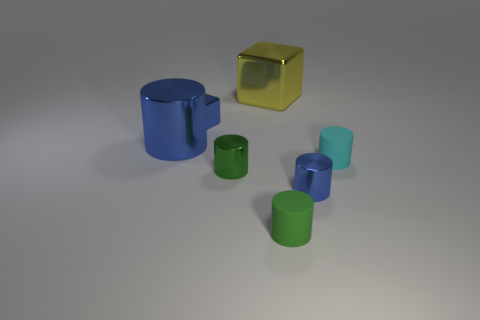Is there any other thing that is the same color as the big block?
Offer a terse response. No. There is a blue block; are there any big yellow objects on the right side of it?
Your answer should be very brief. Yes. Is the shape of the blue shiny object in front of the cyan rubber cylinder the same as  the large yellow object?
Provide a succinct answer. No. How many large things have the same color as the big metallic block?
Give a very brief answer. 0. There is a blue object that is in front of the large object in front of the yellow thing; what shape is it?
Make the answer very short. Cylinder. Are there any other tiny things of the same shape as the green matte thing?
Give a very brief answer. Yes. Do the tiny block and the metallic thing left of the tiny metal cube have the same color?
Offer a terse response. Yes. Is there a metallic block that has the same size as the green metallic cylinder?
Ensure brevity in your answer.  Yes. Is the tiny cyan cylinder made of the same material as the blue thing in front of the tiny cyan cylinder?
Your response must be concise. No. Is the number of tiny cyan metal cylinders greater than the number of tiny blue metal things?
Provide a succinct answer. No. 